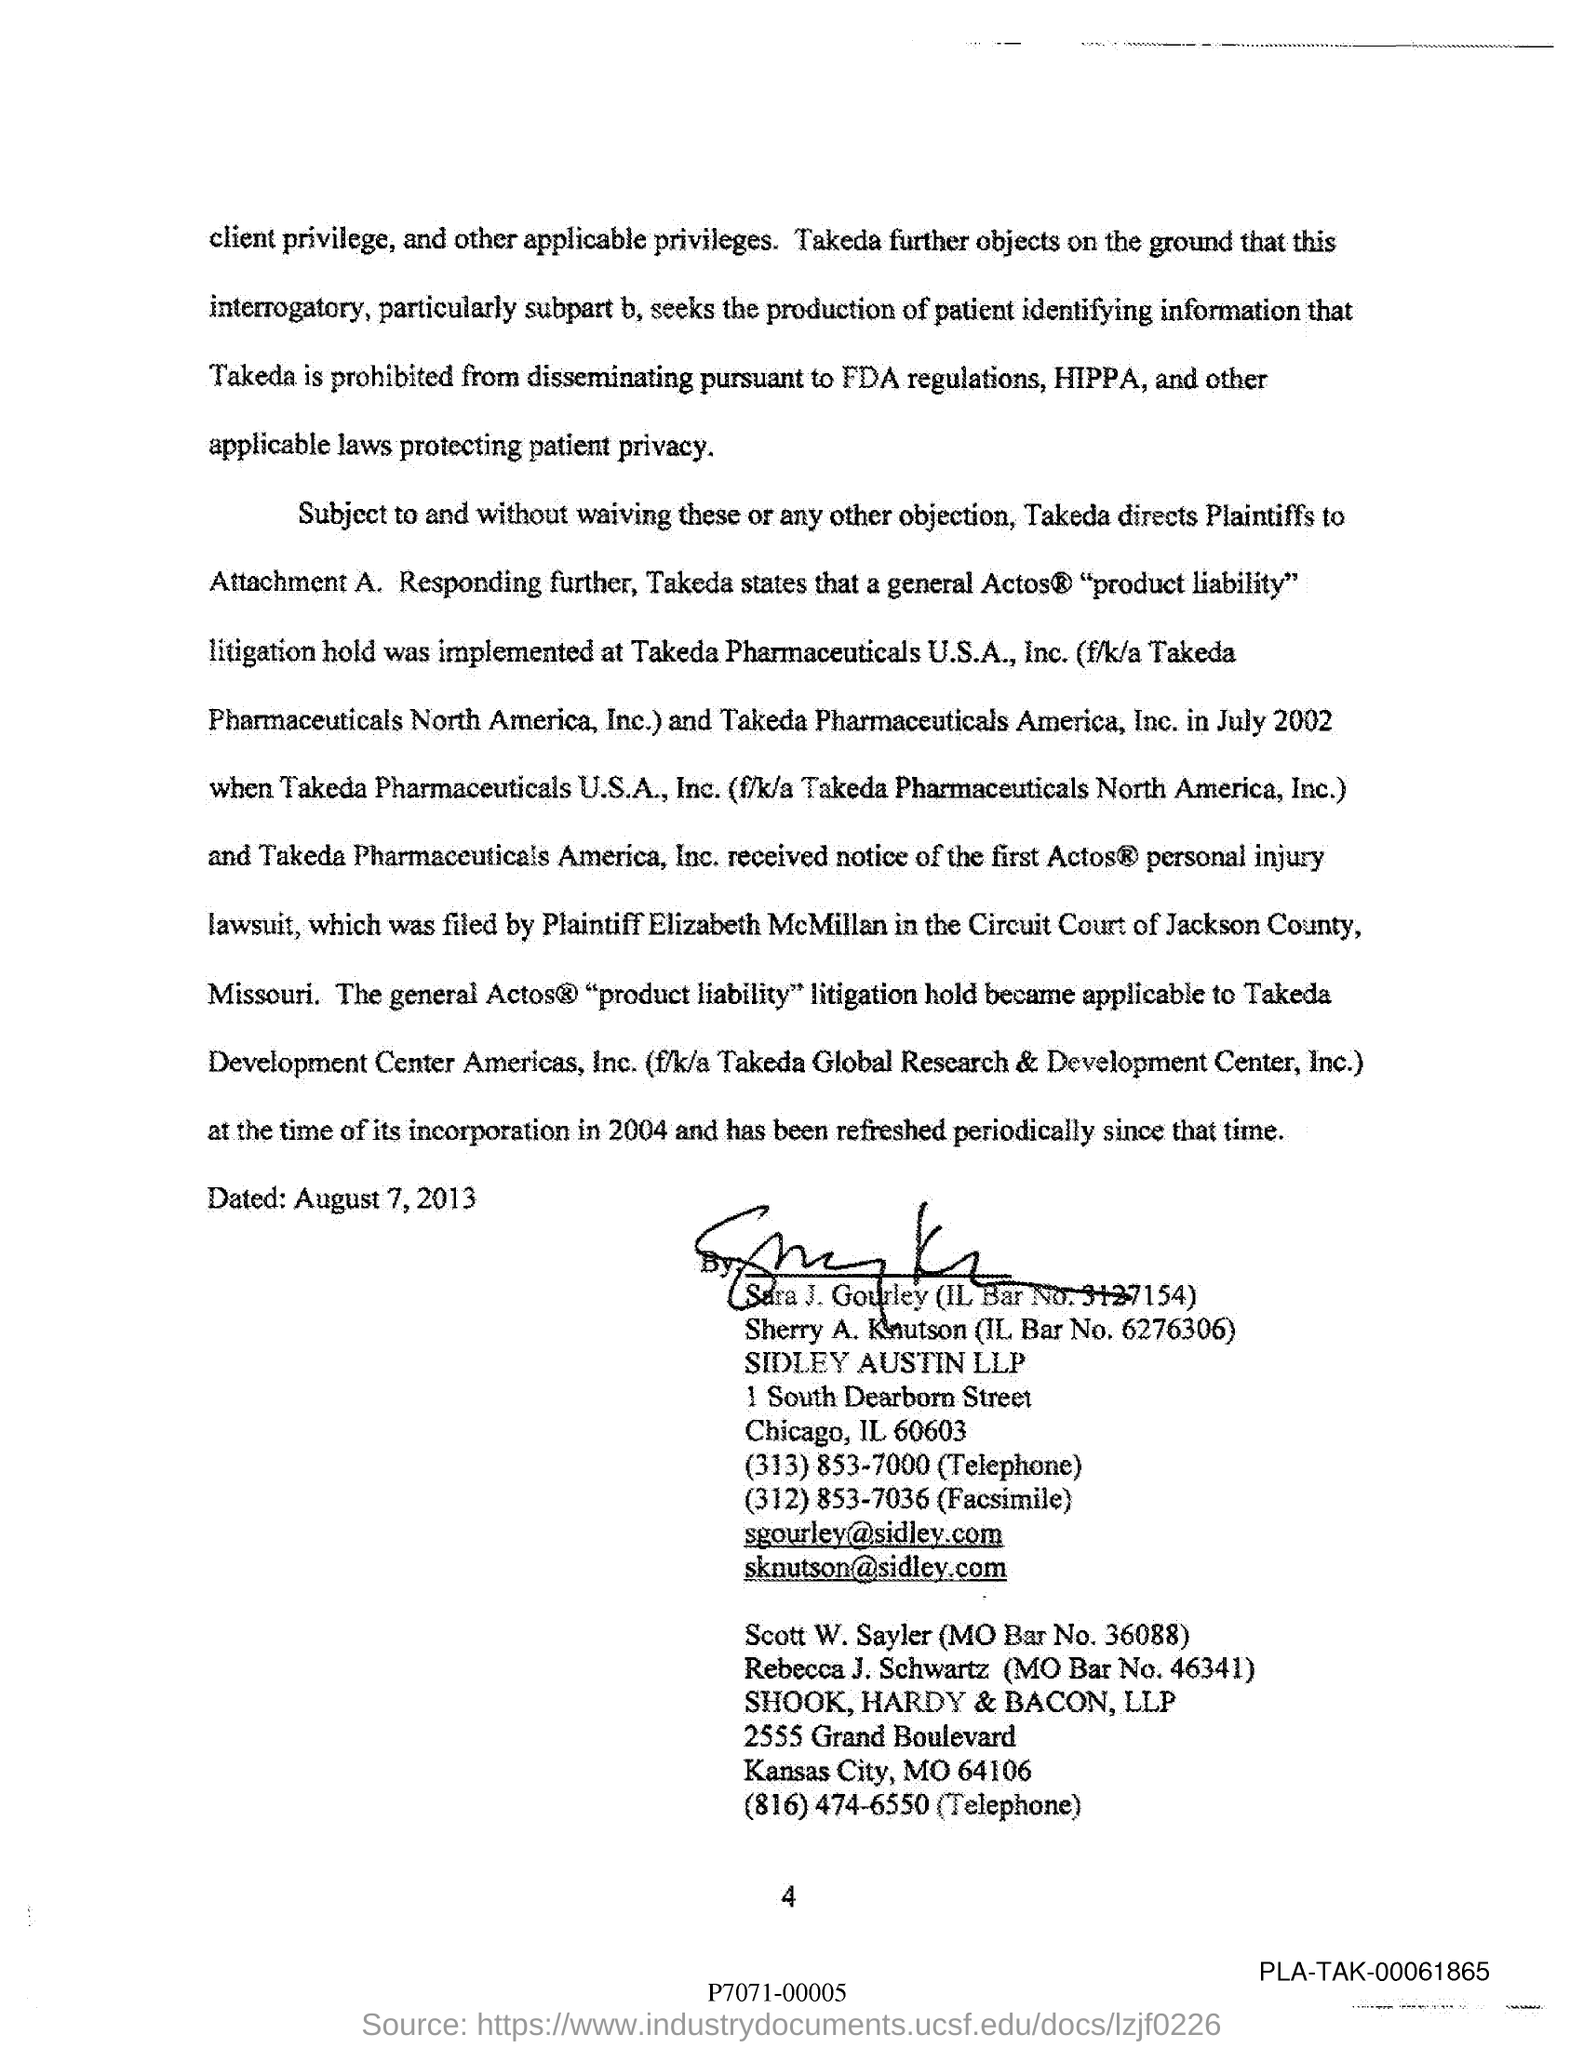What is the IL Bar No. of Sara J. Gourley?
Provide a succinct answer. 3127154. What is the email id of Sara J. Gourley?
Offer a very short reply. Sgourley@sidley.com. What is the MO Bar No. of Scott W. Sayler?
Keep it short and to the point. 36088. 